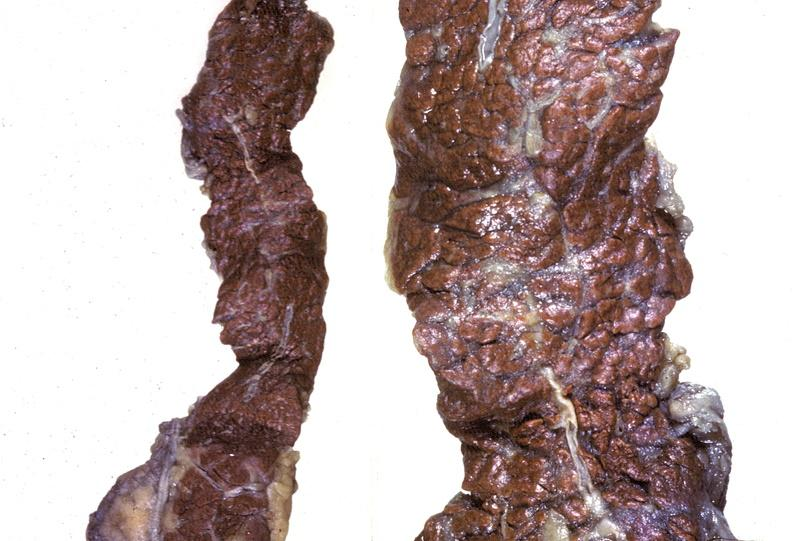does this image show pancreas, hemochromatosis?
Answer the question using a single word or phrase. Yes 